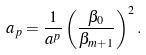<formula> <loc_0><loc_0><loc_500><loc_500>a _ { p } = \frac { 1 } { a ^ { p } } \left ( \frac { \beta _ { 0 } } { \beta _ { m + 1 } } \right ) ^ { 2 } .</formula> 